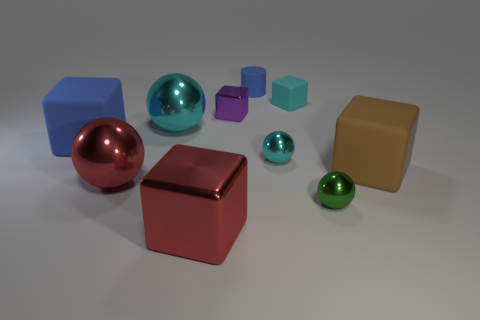Are there more cyan metallic balls than tiny cylinders?
Keep it short and to the point. Yes. What number of big objects have the same color as the small rubber cylinder?
Offer a very short reply. 1. There is another tiny metal object that is the same shape as the tiny green metal object; what color is it?
Provide a succinct answer. Cyan. What is the material of the ball that is both to the left of the tiny blue object and right of the large red sphere?
Give a very brief answer. Metal. Is the small cyan object that is in front of the large cyan shiny ball made of the same material as the small cube on the right side of the blue matte cylinder?
Your answer should be compact. No. What size is the green metal object?
Keep it short and to the point. Small. What is the size of the brown thing that is the same shape as the purple object?
Keep it short and to the point. Large. There is a big brown block; what number of big red shiny spheres are to the right of it?
Keep it short and to the point. 0. What is the color of the big matte block to the right of the large red thing that is in front of the small green metal thing?
Give a very brief answer. Brown. Is there anything else that has the same shape as the tiny green metallic object?
Provide a succinct answer. Yes. 